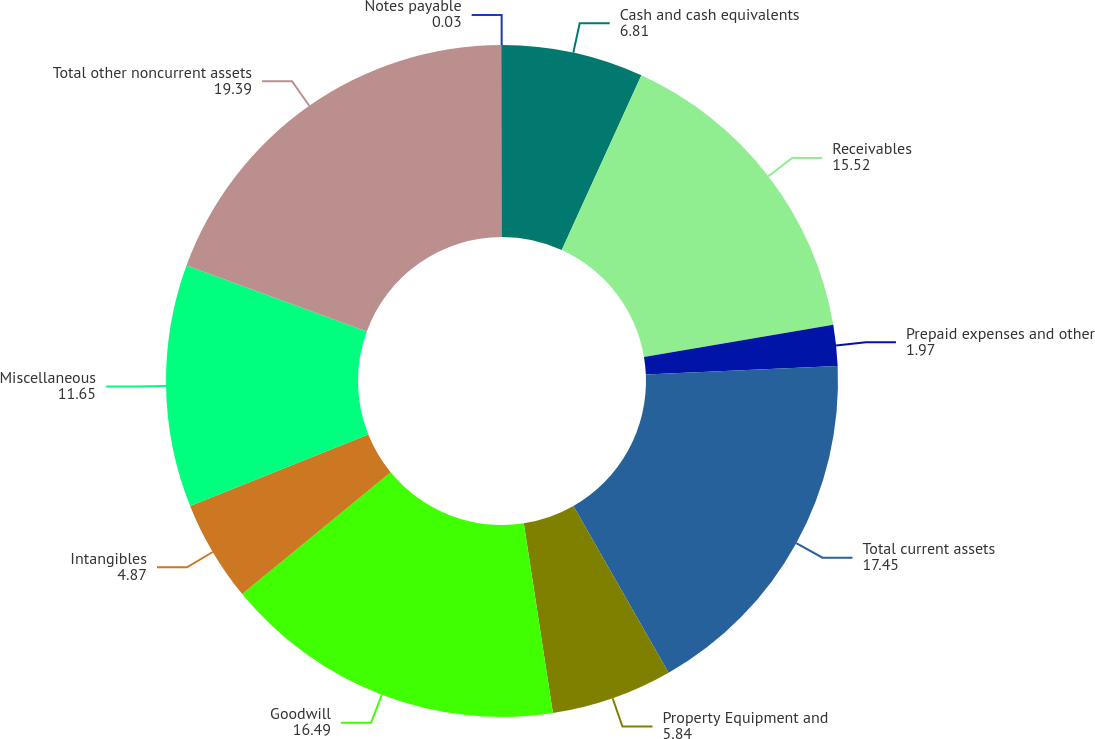Convert chart. <chart><loc_0><loc_0><loc_500><loc_500><pie_chart><fcel>Cash and cash equivalents<fcel>Receivables<fcel>Prepaid expenses and other<fcel>Total current assets<fcel>Property Equipment and<fcel>Goodwill<fcel>Intangibles<fcel>Miscellaneous<fcel>Total other noncurrent assets<fcel>Notes payable<nl><fcel>6.81%<fcel>15.52%<fcel>1.97%<fcel>17.45%<fcel>5.84%<fcel>16.49%<fcel>4.87%<fcel>11.65%<fcel>19.39%<fcel>0.03%<nl></chart> 